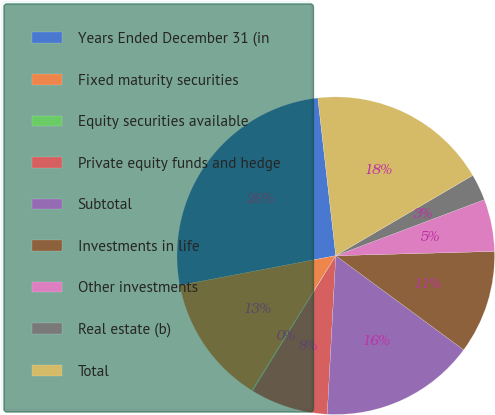<chart> <loc_0><loc_0><loc_500><loc_500><pie_chart><fcel>Years Ended December 31 (in<fcel>Fixed maturity securities<fcel>Equity securities available<fcel>Private equity funds and hedge<fcel>Subtotal<fcel>Investments in life<fcel>Other investments<fcel>Real estate (b)<fcel>Total<nl><fcel>26.19%<fcel>13.14%<fcel>0.09%<fcel>7.92%<fcel>15.75%<fcel>10.53%<fcel>5.31%<fcel>2.7%<fcel>18.36%<nl></chart> 